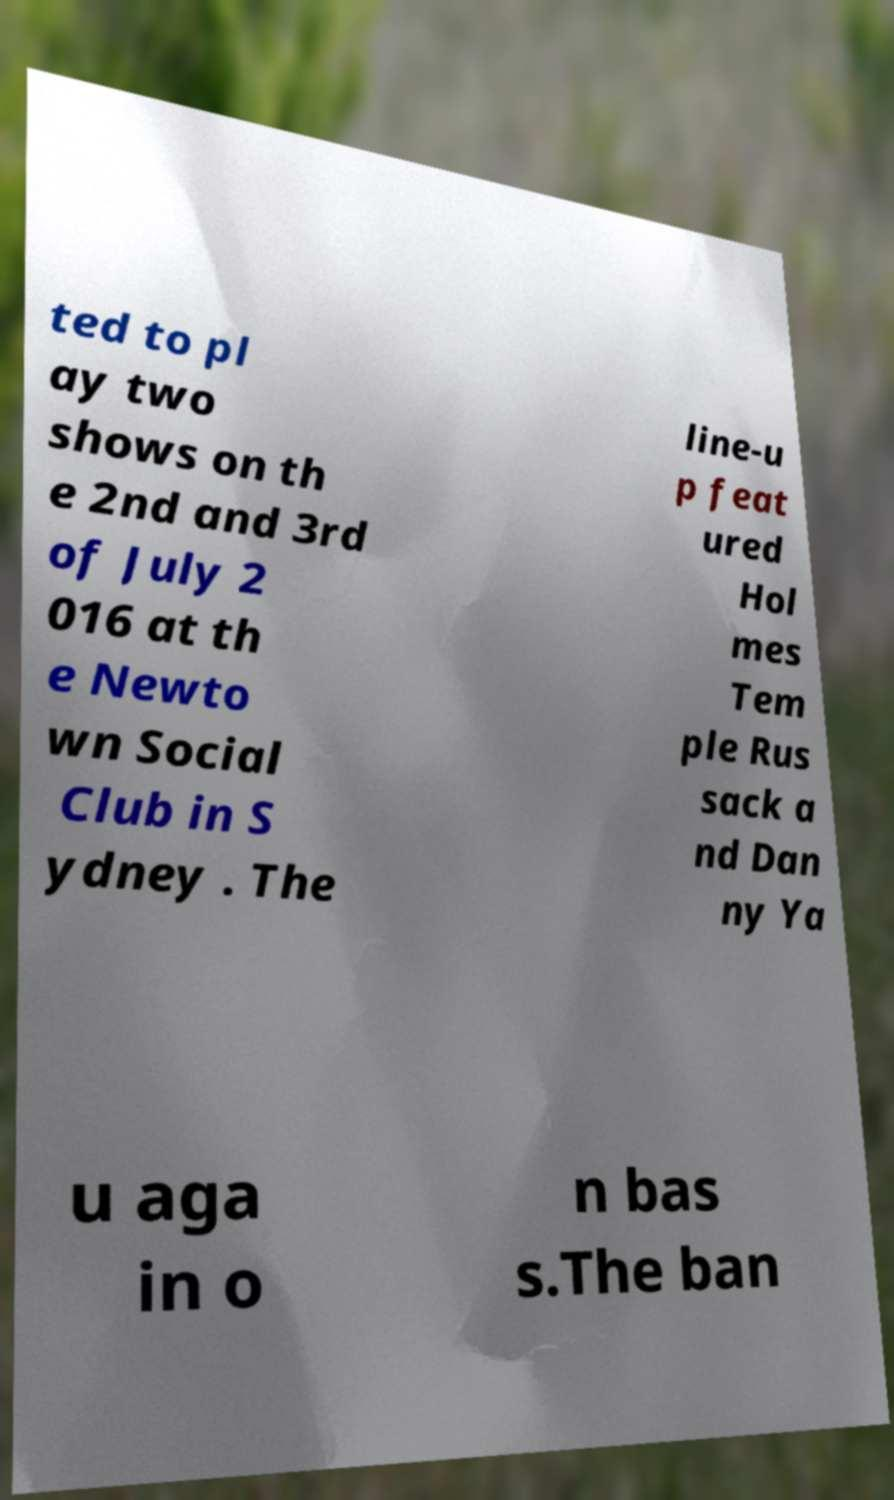There's text embedded in this image that I need extracted. Can you transcribe it verbatim? ted to pl ay two shows on th e 2nd and 3rd of July 2 016 at th e Newto wn Social Club in S ydney . The line-u p feat ured Hol mes Tem ple Rus sack a nd Dan ny Ya u aga in o n bas s.The ban 